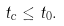<formula> <loc_0><loc_0><loc_500><loc_500>t _ { c } \leq t _ { 0 } .</formula> 